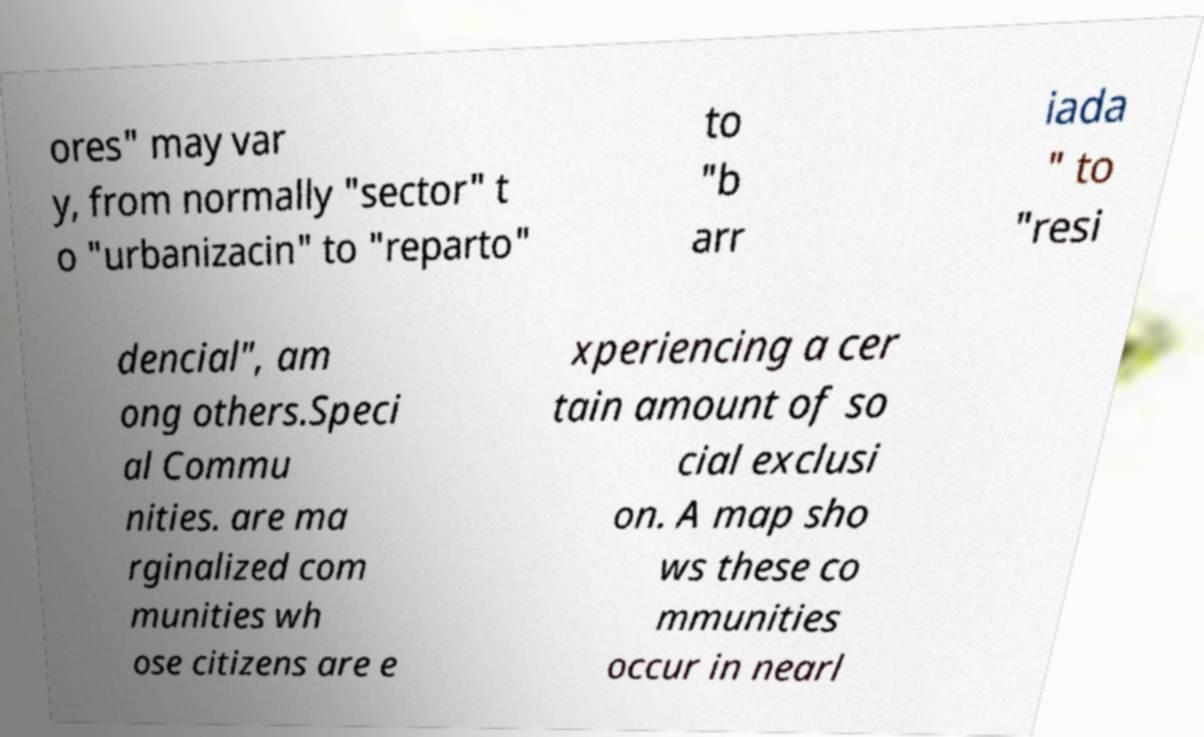Could you extract and type out the text from this image? ores" may var y, from normally "sector" t o "urbanizacin" to "reparto" to "b arr iada " to "resi dencial", am ong others.Speci al Commu nities. are ma rginalized com munities wh ose citizens are e xperiencing a cer tain amount of so cial exclusi on. A map sho ws these co mmunities occur in nearl 